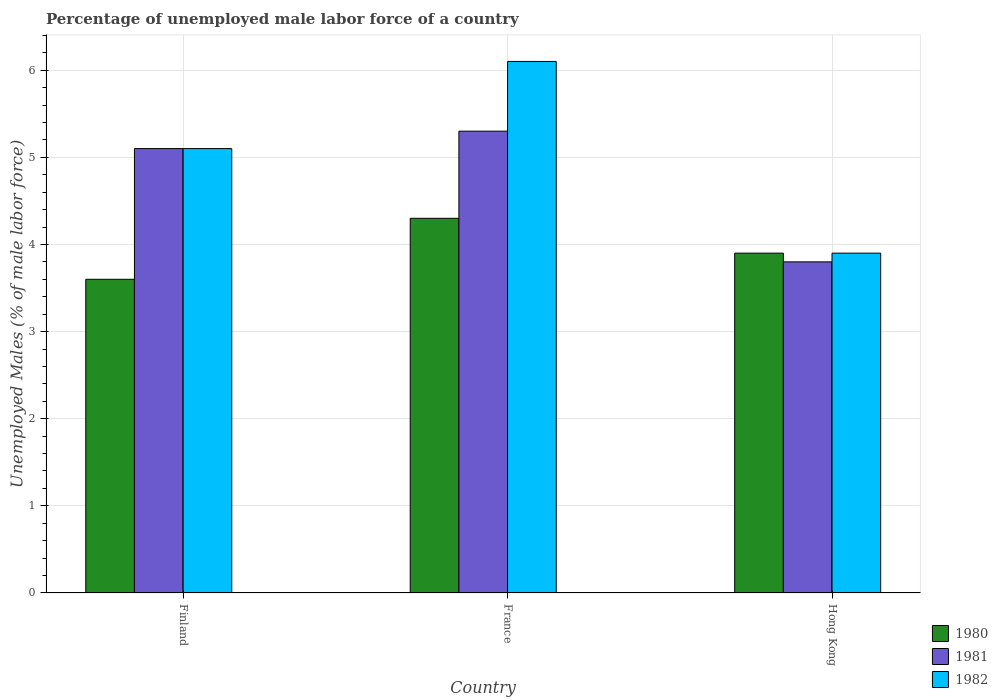How many groups of bars are there?
Give a very brief answer. 3. Are the number of bars per tick equal to the number of legend labels?
Ensure brevity in your answer.  Yes. In how many cases, is the number of bars for a given country not equal to the number of legend labels?
Keep it short and to the point. 0. What is the percentage of unemployed male labor force in 1982 in Hong Kong?
Offer a terse response. 3.9. Across all countries, what is the maximum percentage of unemployed male labor force in 1982?
Ensure brevity in your answer.  6.1. Across all countries, what is the minimum percentage of unemployed male labor force in 1981?
Your answer should be compact. 3.8. What is the total percentage of unemployed male labor force in 1981 in the graph?
Keep it short and to the point. 14.2. What is the difference between the percentage of unemployed male labor force in 1981 in Finland and that in France?
Ensure brevity in your answer.  -0.2. What is the difference between the percentage of unemployed male labor force in 1982 in France and the percentage of unemployed male labor force in 1981 in Finland?
Offer a terse response. 1. What is the average percentage of unemployed male labor force in 1981 per country?
Your answer should be compact. 4.73. What is the difference between the percentage of unemployed male labor force of/in 1980 and percentage of unemployed male labor force of/in 1981 in Hong Kong?
Your response must be concise. 0.1. What is the ratio of the percentage of unemployed male labor force in 1982 in Finland to that in Hong Kong?
Your answer should be very brief. 1.31. Is the difference between the percentage of unemployed male labor force in 1980 in France and Hong Kong greater than the difference between the percentage of unemployed male labor force in 1981 in France and Hong Kong?
Offer a very short reply. No. What is the difference between the highest and the second highest percentage of unemployed male labor force in 1980?
Give a very brief answer. -0.3. What is the difference between the highest and the lowest percentage of unemployed male labor force in 1981?
Offer a very short reply. 1.5. In how many countries, is the percentage of unemployed male labor force in 1980 greater than the average percentage of unemployed male labor force in 1980 taken over all countries?
Your answer should be very brief. 1. How many countries are there in the graph?
Provide a short and direct response. 3. What is the difference between two consecutive major ticks on the Y-axis?
Offer a very short reply. 1. Are the values on the major ticks of Y-axis written in scientific E-notation?
Ensure brevity in your answer.  No. Does the graph contain any zero values?
Offer a terse response. No. Does the graph contain grids?
Your answer should be very brief. Yes. Where does the legend appear in the graph?
Make the answer very short. Bottom right. How many legend labels are there?
Make the answer very short. 3. How are the legend labels stacked?
Give a very brief answer. Vertical. What is the title of the graph?
Offer a very short reply. Percentage of unemployed male labor force of a country. Does "2013" appear as one of the legend labels in the graph?
Offer a very short reply. No. What is the label or title of the X-axis?
Offer a very short reply. Country. What is the label or title of the Y-axis?
Give a very brief answer. Unemployed Males (% of male labor force). What is the Unemployed Males (% of male labor force) in 1980 in Finland?
Provide a short and direct response. 3.6. What is the Unemployed Males (% of male labor force) of 1981 in Finland?
Make the answer very short. 5.1. What is the Unemployed Males (% of male labor force) of 1982 in Finland?
Provide a short and direct response. 5.1. What is the Unemployed Males (% of male labor force) in 1980 in France?
Give a very brief answer. 4.3. What is the Unemployed Males (% of male labor force) of 1981 in France?
Your answer should be compact. 5.3. What is the Unemployed Males (% of male labor force) in 1982 in France?
Make the answer very short. 6.1. What is the Unemployed Males (% of male labor force) in 1980 in Hong Kong?
Ensure brevity in your answer.  3.9. What is the Unemployed Males (% of male labor force) in 1981 in Hong Kong?
Your answer should be compact. 3.8. What is the Unemployed Males (% of male labor force) of 1982 in Hong Kong?
Give a very brief answer. 3.9. Across all countries, what is the maximum Unemployed Males (% of male labor force) of 1980?
Keep it short and to the point. 4.3. Across all countries, what is the maximum Unemployed Males (% of male labor force) of 1981?
Offer a terse response. 5.3. Across all countries, what is the maximum Unemployed Males (% of male labor force) of 1982?
Your answer should be very brief. 6.1. Across all countries, what is the minimum Unemployed Males (% of male labor force) of 1980?
Provide a short and direct response. 3.6. Across all countries, what is the minimum Unemployed Males (% of male labor force) in 1981?
Offer a very short reply. 3.8. Across all countries, what is the minimum Unemployed Males (% of male labor force) in 1982?
Ensure brevity in your answer.  3.9. What is the total Unemployed Males (% of male labor force) in 1982 in the graph?
Provide a succinct answer. 15.1. What is the difference between the Unemployed Males (% of male labor force) of 1980 in Finland and that in France?
Your answer should be compact. -0.7. What is the difference between the Unemployed Males (% of male labor force) of 1982 in Finland and that in France?
Keep it short and to the point. -1. What is the difference between the Unemployed Males (% of male labor force) of 1980 in Finland and that in Hong Kong?
Provide a succinct answer. -0.3. What is the difference between the Unemployed Males (% of male labor force) of 1981 in Finland and that in Hong Kong?
Keep it short and to the point. 1.3. What is the difference between the Unemployed Males (% of male labor force) in 1982 in France and that in Hong Kong?
Offer a very short reply. 2.2. What is the difference between the Unemployed Males (% of male labor force) in 1980 in Finland and the Unemployed Males (% of male labor force) in 1981 in France?
Provide a succinct answer. -1.7. What is the difference between the Unemployed Males (% of male labor force) of 1981 in Finland and the Unemployed Males (% of male labor force) of 1982 in France?
Keep it short and to the point. -1. What is the difference between the Unemployed Males (% of male labor force) of 1981 in Finland and the Unemployed Males (% of male labor force) of 1982 in Hong Kong?
Your response must be concise. 1.2. What is the difference between the Unemployed Males (% of male labor force) of 1980 in France and the Unemployed Males (% of male labor force) of 1982 in Hong Kong?
Provide a short and direct response. 0.4. What is the average Unemployed Males (% of male labor force) in 1980 per country?
Offer a very short reply. 3.93. What is the average Unemployed Males (% of male labor force) of 1981 per country?
Offer a terse response. 4.73. What is the average Unemployed Males (% of male labor force) in 1982 per country?
Provide a short and direct response. 5.03. What is the difference between the Unemployed Males (% of male labor force) of 1980 and Unemployed Males (% of male labor force) of 1981 in Finland?
Offer a terse response. -1.5. What is the difference between the Unemployed Males (% of male labor force) in 1980 and Unemployed Males (% of male labor force) in 1982 in Finland?
Make the answer very short. -1.5. What is the difference between the Unemployed Males (% of male labor force) in 1981 and Unemployed Males (% of male labor force) in 1982 in Finland?
Provide a short and direct response. 0. What is the difference between the Unemployed Males (% of male labor force) in 1980 and Unemployed Males (% of male labor force) in 1981 in France?
Provide a short and direct response. -1. What is the difference between the Unemployed Males (% of male labor force) of 1980 and Unemployed Males (% of male labor force) of 1982 in France?
Your response must be concise. -1.8. What is the difference between the Unemployed Males (% of male labor force) of 1980 and Unemployed Males (% of male labor force) of 1982 in Hong Kong?
Provide a short and direct response. 0. What is the difference between the Unemployed Males (% of male labor force) in 1981 and Unemployed Males (% of male labor force) in 1982 in Hong Kong?
Your answer should be compact. -0.1. What is the ratio of the Unemployed Males (% of male labor force) of 1980 in Finland to that in France?
Provide a short and direct response. 0.84. What is the ratio of the Unemployed Males (% of male labor force) of 1981 in Finland to that in France?
Provide a succinct answer. 0.96. What is the ratio of the Unemployed Males (% of male labor force) in 1982 in Finland to that in France?
Make the answer very short. 0.84. What is the ratio of the Unemployed Males (% of male labor force) of 1980 in Finland to that in Hong Kong?
Ensure brevity in your answer.  0.92. What is the ratio of the Unemployed Males (% of male labor force) of 1981 in Finland to that in Hong Kong?
Provide a short and direct response. 1.34. What is the ratio of the Unemployed Males (% of male labor force) in 1982 in Finland to that in Hong Kong?
Offer a very short reply. 1.31. What is the ratio of the Unemployed Males (% of male labor force) of 1980 in France to that in Hong Kong?
Provide a succinct answer. 1.1. What is the ratio of the Unemployed Males (% of male labor force) in 1981 in France to that in Hong Kong?
Keep it short and to the point. 1.39. What is the ratio of the Unemployed Males (% of male labor force) of 1982 in France to that in Hong Kong?
Provide a succinct answer. 1.56. What is the difference between the highest and the lowest Unemployed Males (% of male labor force) of 1980?
Offer a terse response. 0.7. What is the difference between the highest and the lowest Unemployed Males (% of male labor force) in 1981?
Keep it short and to the point. 1.5. 